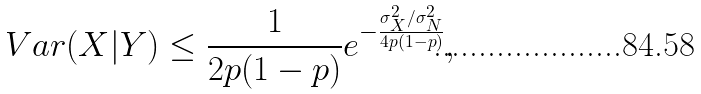Convert formula to latex. <formula><loc_0><loc_0><loc_500><loc_500>V a r ( X | Y ) \leq \frac { 1 } { 2 p ( 1 - p ) } e ^ { - \frac { \sigma _ { X } ^ { 2 } / \sigma _ { N } ^ { 2 } } { 4 p ( 1 - p ) } } ,</formula> 